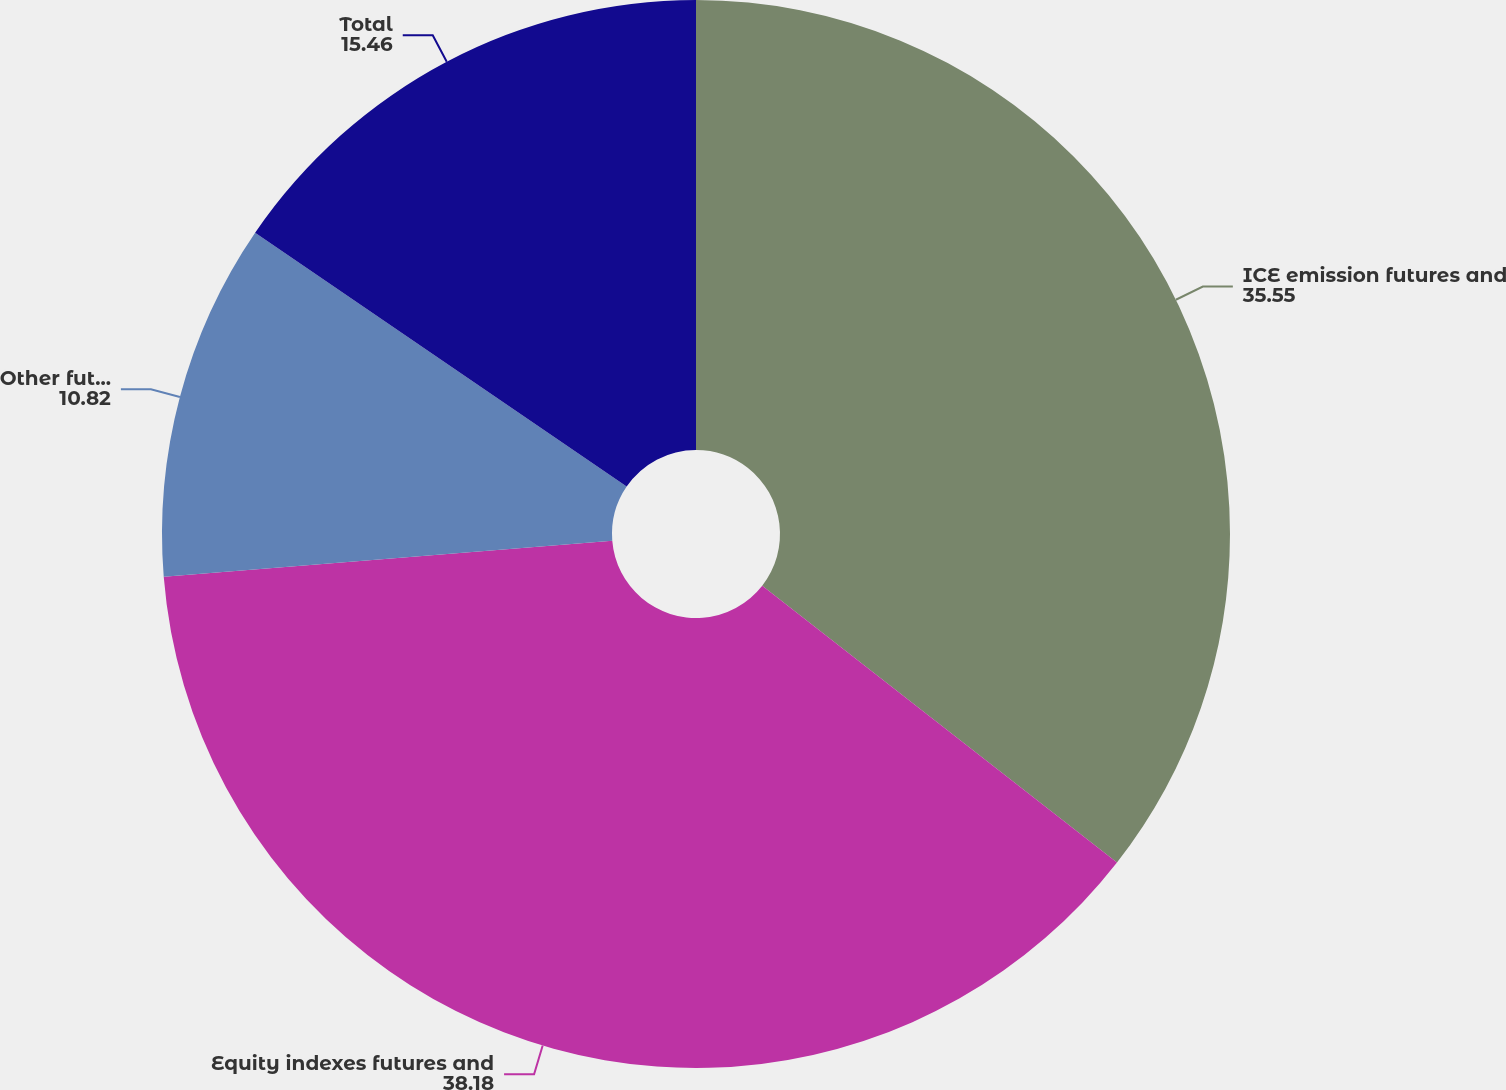<chart> <loc_0><loc_0><loc_500><loc_500><pie_chart><fcel>ICE emission futures and<fcel>Equity indexes futures and<fcel>Other futures and options<fcel>Total<nl><fcel>35.55%<fcel>38.18%<fcel>10.82%<fcel>15.46%<nl></chart> 